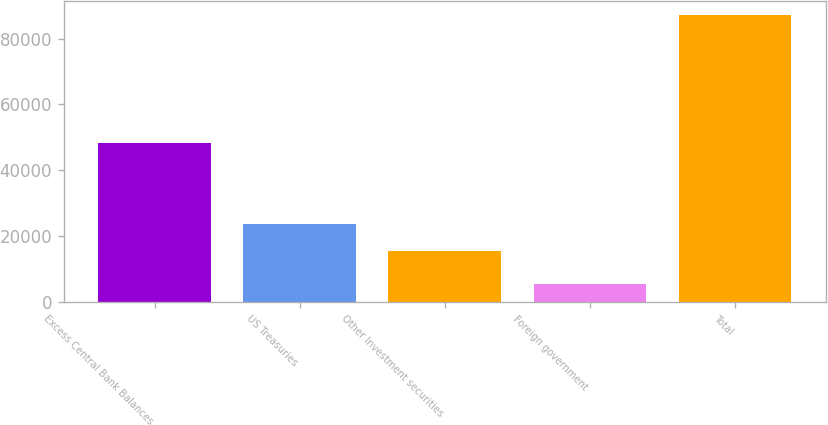Convert chart. <chart><loc_0><loc_0><loc_500><loc_500><bar_chart><fcel>Excess Central Bank Balances<fcel>US Treasuries<fcel>Other Investment securities<fcel>Foreign government<fcel>Total<nl><fcel>48407<fcel>23603.9<fcel>15442<fcel>5585<fcel>87204<nl></chart> 